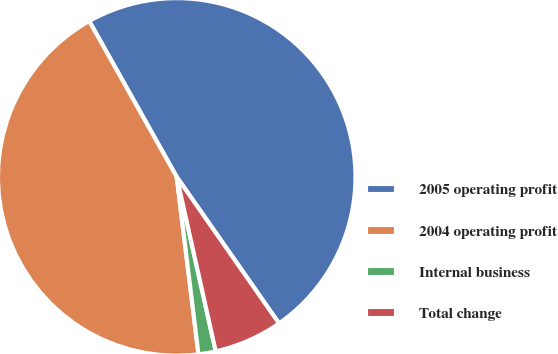Convert chart to OTSL. <chart><loc_0><loc_0><loc_500><loc_500><pie_chart><fcel>2005 operating profit<fcel>2004 operating profit<fcel>Internal business<fcel>Total change<nl><fcel>48.44%<fcel>43.8%<fcel>1.56%<fcel>6.2%<nl></chart> 